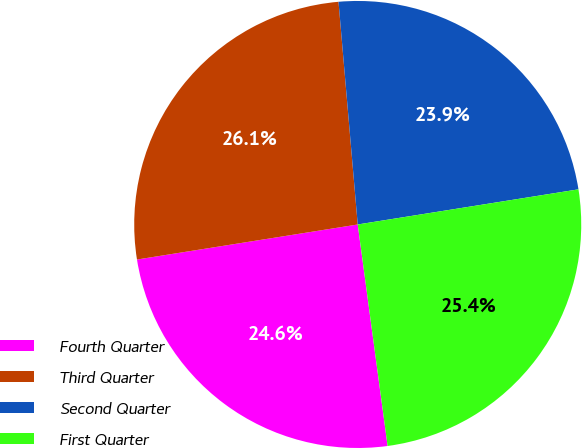<chart> <loc_0><loc_0><loc_500><loc_500><pie_chart><fcel>Fourth Quarter<fcel>Third Quarter<fcel>Second Quarter<fcel>First Quarter<nl><fcel>24.63%<fcel>26.14%<fcel>23.86%<fcel>25.38%<nl></chart> 